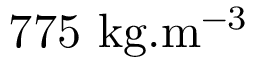Convert formula to latex. <formula><loc_0><loc_0><loc_500><loc_500>7 7 5 k g . m ^ { - 3 }</formula> 